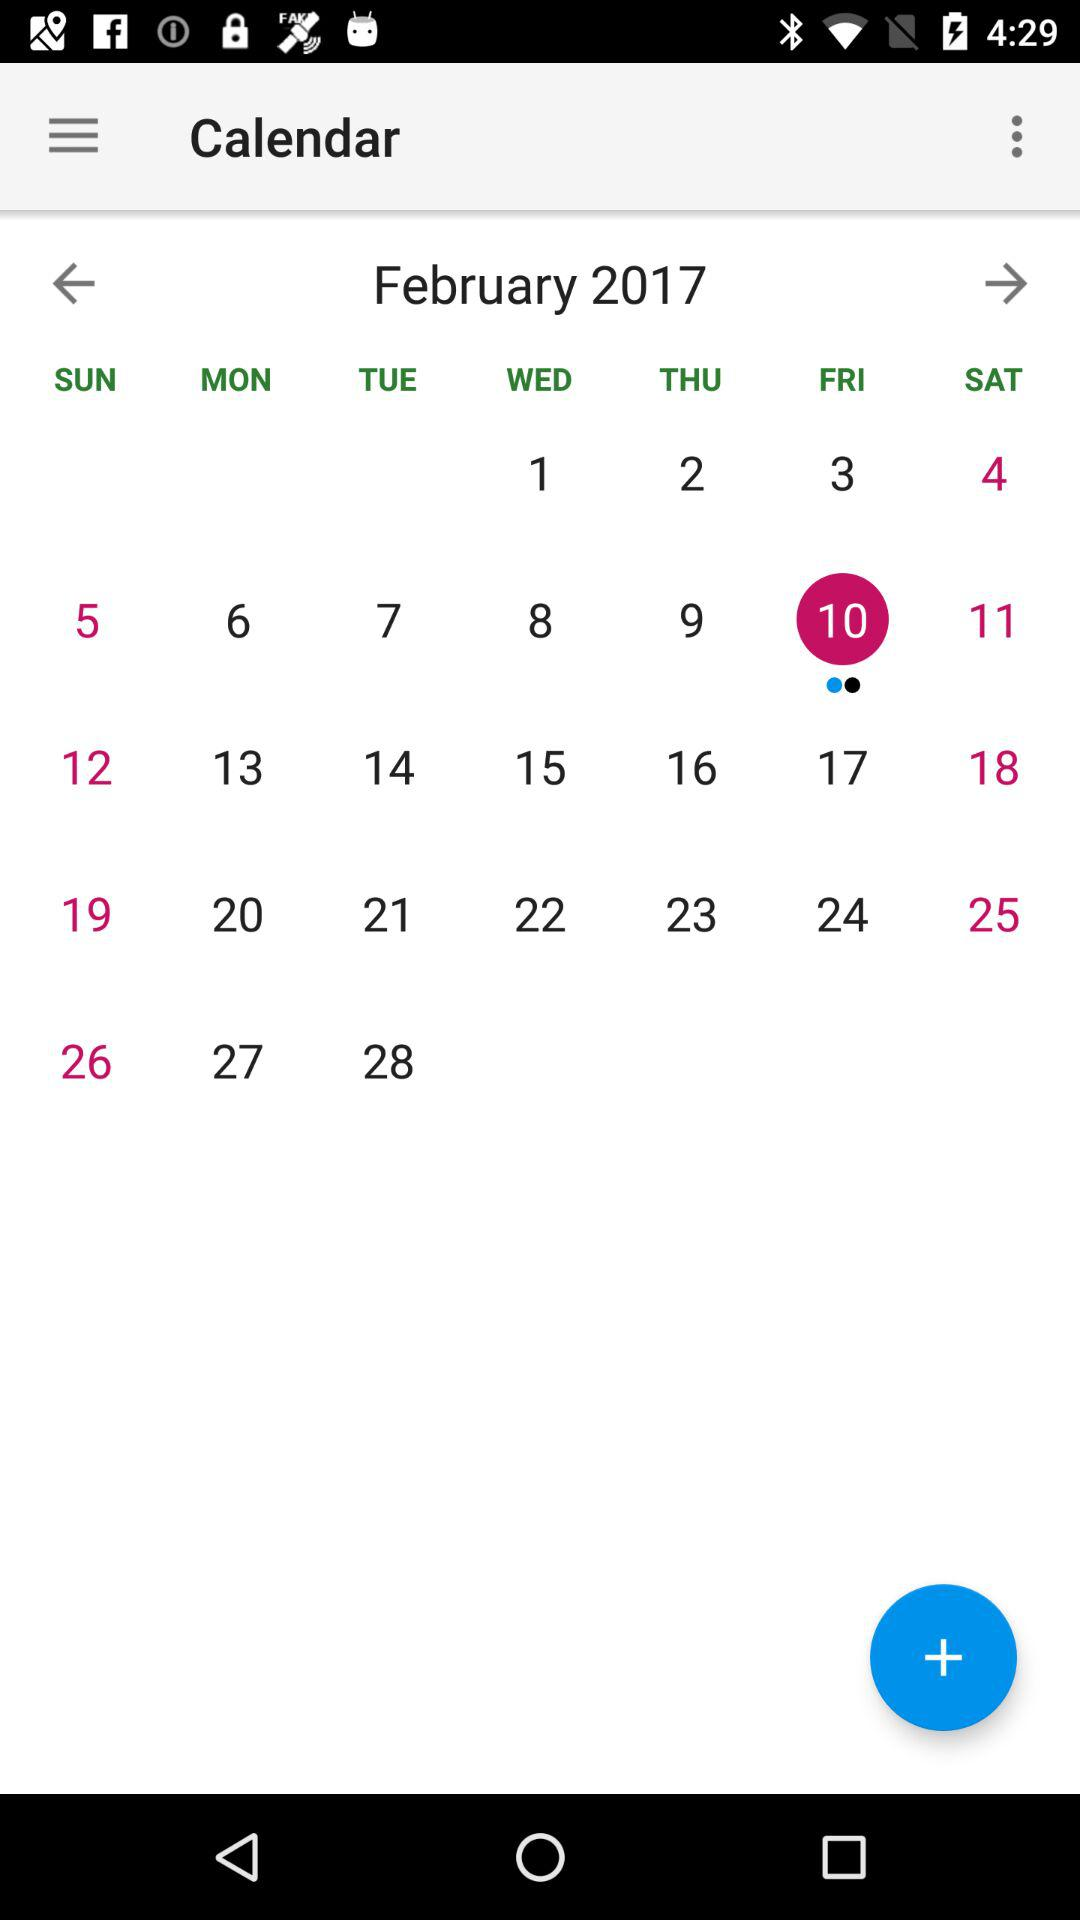What's the selected date? The selected date is Friday, February 10, 2017. 